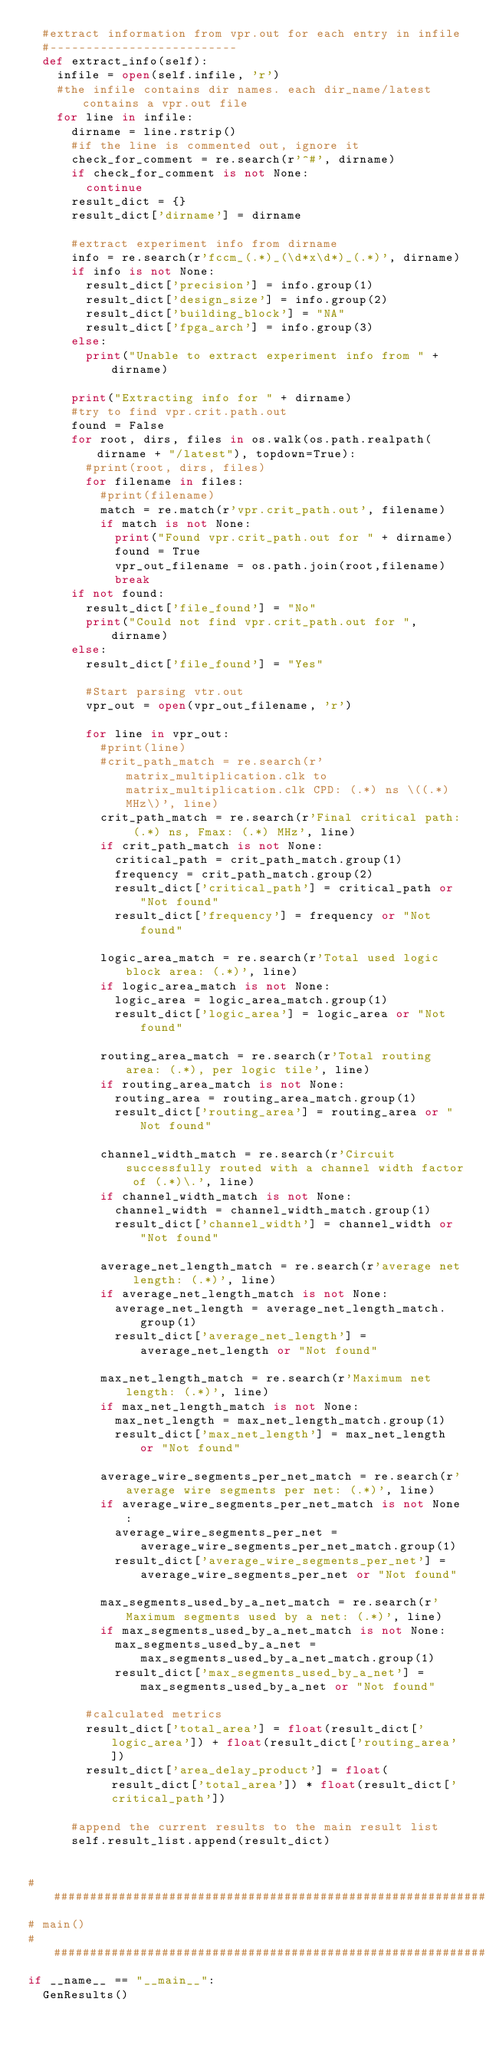<code> <loc_0><loc_0><loc_500><loc_500><_Python_>  #extract information from vpr.out for each entry in infile
  #--------------------------
  def extract_info(self):
    infile = open(self.infile, 'r')
    #the infile contains dir names. each dir_name/latest contains a vpr.out file
    for line in infile:
      dirname = line.rstrip()
      #if the line is commented out, ignore it
      check_for_comment = re.search(r'^#', dirname)
      if check_for_comment is not None:
        continue
      result_dict = {}
      result_dict['dirname'] = dirname 

      #extract experiment info from dirname
      info = re.search(r'fccm_(.*)_(\d*x\d*)_(.*)', dirname)
      if info is not None:
        result_dict['precision'] = info.group(1)
        result_dict['design_size'] = info.group(2)
        result_dict['building_block'] = "NA"
        result_dict['fpga_arch'] = info.group(3)
      else:
        print("Unable to extract experiment info from " + dirname)

      print("Extracting info for " + dirname)
      #try to find vpr.crit.path.out
      found = False
      for root, dirs, files in os.walk(os.path.realpath(dirname + "/latest"), topdown=True):
        #print(root, dirs, files)
        for filename in files:
          #print(filename)
          match = re.match(r'vpr.crit_path.out', filename)
          if match is not None:
            print("Found vpr.crit_path.out for " + dirname)
            found = True
            vpr_out_filename = os.path.join(root,filename)
            break
      if not found:
        result_dict['file_found'] = "No" 
        print("Could not find vpr.crit_path.out for ", dirname)
      else:      
        result_dict['file_found'] = "Yes" 

        #Start parsing vtr.out
        vpr_out = open(vpr_out_filename, 'r')

        for line in vpr_out:
          #print(line)
          #crit_path_match = re.search(r'matrix_multiplication.clk to matrix_multiplication.clk CPD: (.*) ns \((.*) MHz\)', line)
          crit_path_match = re.search(r'Final critical path: (.*) ns, Fmax: (.*) MHz', line)
          if crit_path_match is not None:
            critical_path = crit_path_match.group(1)
            frequency = crit_path_match.group(2)
            result_dict['critical_path'] = critical_path or "Not found"
            result_dict['frequency'] = frequency or "Not found"

          logic_area_match = re.search(r'Total used logic block area: (.*)', line)
          if logic_area_match is not None:
            logic_area = logic_area_match.group(1)
            result_dict['logic_area'] = logic_area or "Not found"

          routing_area_match = re.search(r'Total routing area: (.*), per logic tile', line)
          if routing_area_match is not None:
            routing_area = routing_area_match.group(1)
            result_dict['routing_area'] = routing_area or "Not found"

          channel_width_match = re.search(r'Circuit successfully routed with a channel width factor of (.*)\.', line)
          if channel_width_match is not None:
            channel_width = channel_width_match.group(1)
            result_dict['channel_width'] = channel_width or "Not found"

          average_net_length_match = re.search(r'average net length: (.*)', line)
          if average_net_length_match is not None:
            average_net_length = average_net_length_match.group(1)
            result_dict['average_net_length'] = average_net_length or "Not found"

          max_net_length_match = re.search(r'Maximum net length: (.*)', line)
          if max_net_length_match is not None:
            max_net_length = max_net_length_match.group(1)
            result_dict['max_net_length'] = max_net_length or "Not found"

          average_wire_segments_per_net_match = re.search(r'average wire segments per net: (.*)', line)
          if average_wire_segments_per_net_match is not None:
            average_wire_segments_per_net = average_wire_segments_per_net_match.group(1)
            result_dict['average_wire_segments_per_net'] = average_wire_segments_per_net or "Not found"

          max_segments_used_by_a_net_match = re.search(r'Maximum segments used by a net: (.*)', line)
          if max_segments_used_by_a_net_match is not None:
            max_segments_used_by_a_net = max_segments_used_by_a_net_match.group(1)
            result_dict['max_segments_used_by_a_net'] = max_segments_used_by_a_net or "Not found"
          
        #calculated metrics
        result_dict['total_area'] = float(result_dict['logic_area']) + float(result_dict['routing_area'])
        result_dict['area_delay_product'] = float(result_dict['total_area']) * float(result_dict['critical_path'])

      #append the current results to the main result list
      self.result_list.append(result_dict)
       
  
# ###############################################################
# main()
# ###############################################################
if __name__ == "__main__":
  GenResults()

</code> 